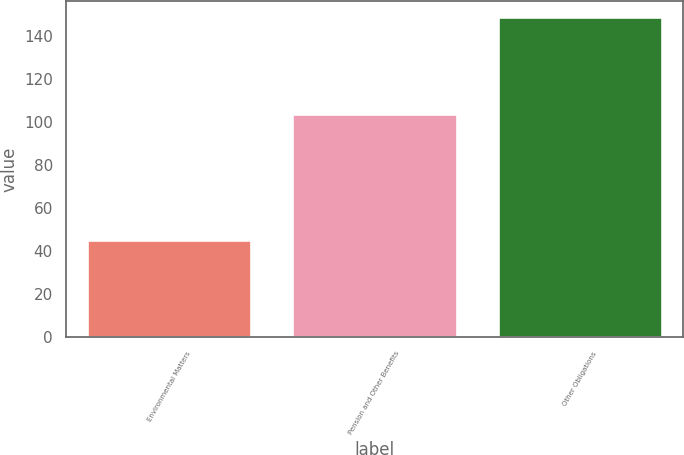Convert chart to OTSL. <chart><loc_0><loc_0><loc_500><loc_500><bar_chart><fcel>Environmental Matters<fcel>Pension and Other Benefits<fcel>Other Obligations<nl><fcel>45<fcel>104<fcel>149<nl></chart> 